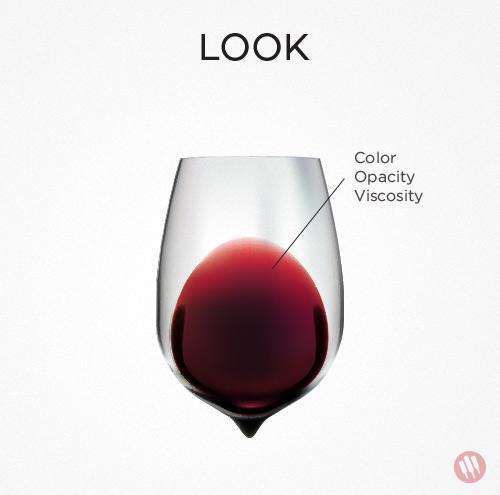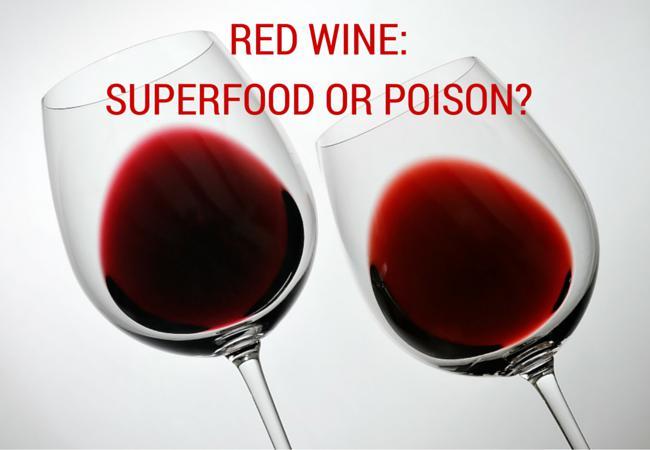The first image is the image on the left, the second image is the image on the right. Considering the images on both sides, is "there are exactly two wine glasses in the image on the right." valid? Answer yes or no. Yes. 